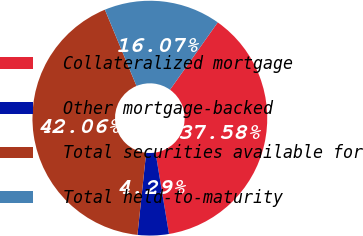Convert chart. <chart><loc_0><loc_0><loc_500><loc_500><pie_chart><fcel>Collateralized mortgage<fcel>Other mortgage-backed<fcel>Total securities available for<fcel>Total held-to-maturity<nl><fcel>37.58%<fcel>4.29%<fcel>42.06%<fcel>16.07%<nl></chart> 